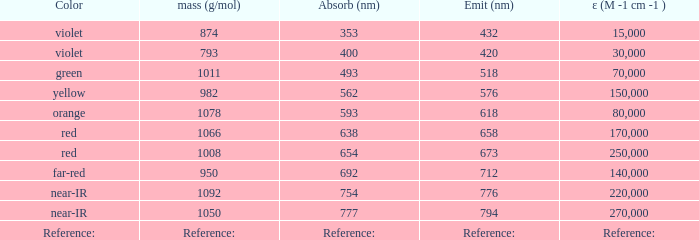Which Emission (in nanometers) that has a molar mass of 1078 g/mol? 618.0. Can you give me this table as a dict? {'header': ['Color', 'mass (g/mol)', 'Absorb (nm)', 'Emit (nm)', 'ε (M -1 cm -1 )'], 'rows': [['violet', '874', '353', '432', '15,000'], ['violet', '793', '400', '420', '30,000'], ['green', '1011', '493', '518', '70,000'], ['yellow', '982', '562', '576', '150,000'], ['orange', '1078', '593', '618', '80,000'], ['red', '1066', '638', '658', '170,000'], ['red', '1008', '654', '673', '250,000'], ['far-red', '950', '692', '712', '140,000'], ['near-IR', '1092', '754', '776', '220,000'], ['near-IR', '1050', '777', '794', '270,000'], ['Reference:', 'Reference:', 'Reference:', 'Reference:', 'Reference:']]} 